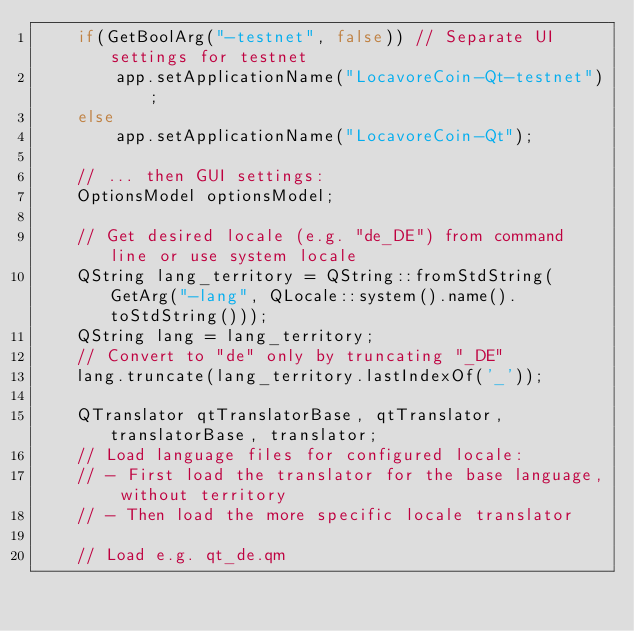Convert code to text. <code><loc_0><loc_0><loc_500><loc_500><_C++_>    if(GetBoolArg("-testnet", false)) // Separate UI settings for testnet
        app.setApplicationName("LocavoreCoin-Qt-testnet");
    else
        app.setApplicationName("LocavoreCoin-Qt");

    // ... then GUI settings:
    OptionsModel optionsModel;

    // Get desired locale (e.g. "de_DE") from command line or use system locale
    QString lang_territory = QString::fromStdString(GetArg("-lang", QLocale::system().name().toStdString()));
    QString lang = lang_territory;
    // Convert to "de" only by truncating "_DE"
    lang.truncate(lang_territory.lastIndexOf('_'));

    QTranslator qtTranslatorBase, qtTranslator, translatorBase, translator;
    // Load language files for configured locale:
    // - First load the translator for the base language, without territory
    // - Then load the more specific locale translator

    // Load e.g. qt_de.qm</code> 